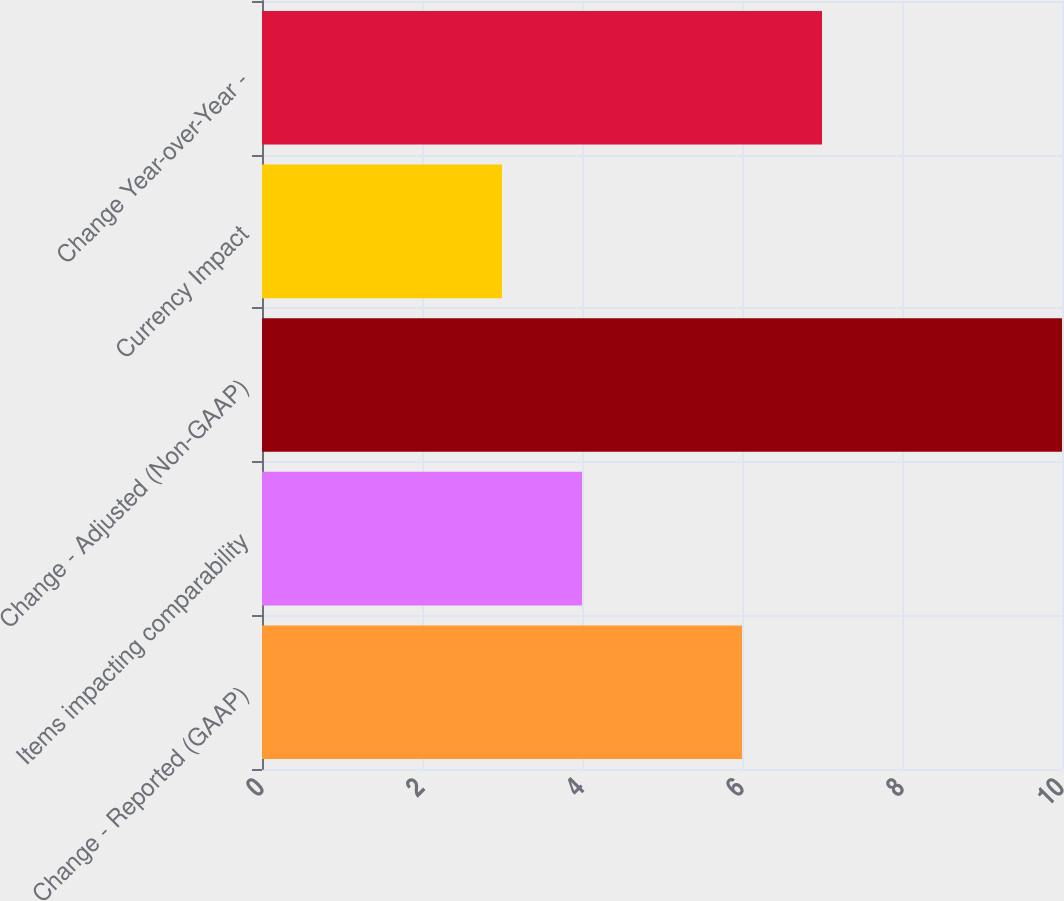<chart> <loc_0><loc_0><loc_500><loc_500><bar_chart><fcel>Change - Reported (GAAP)<fcel>Items impacting comparability<fcel>Change - Adjusted (Non-GAAP)<fcel>Currency Impact<fcel>Change Year-over-Year -<nl><fcel>6<fcel>4<fcel>10<fcel>3<fcel>7<nl></chart> 